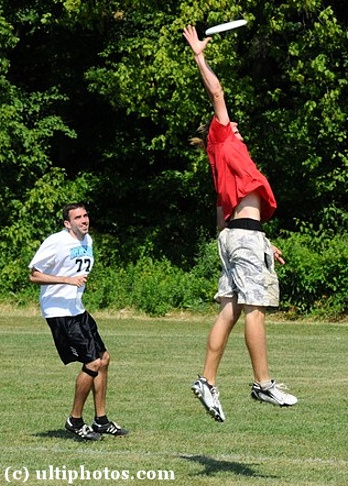Describe the objects in this image and their specific colors. I can see people in darkgreen, lightgray, black, salmon, and tan tones, people in darkgreen, black, white, darkgray, and tan tones, and frisbee in darkgreen, white, gray, darkgray, and black tones in this image. 